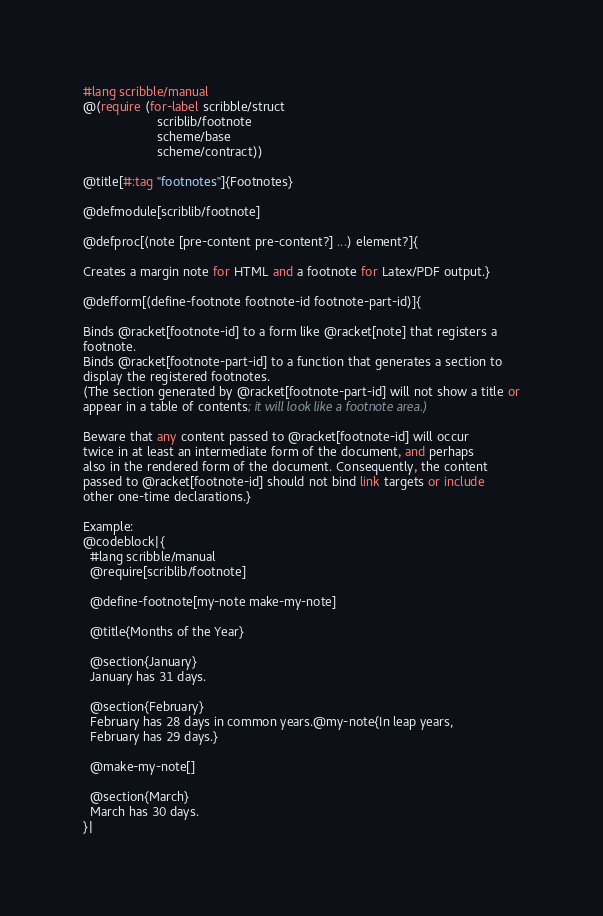Convert code to text. <code><loc_0><loc_0><loc_500><loc_500><_Racket_>#lang scribble/manual
@(require (for-label scribble/struct
                     scriblib/footnote
                     scheme/base
                     scheme/contract))

@title[#:tag "footnotes"]{Footnotes}

@defmodule[scriblib/footnote]

@defproc[(note [pre-content pre-content?] ...) element?]{

Creates a margin note for HTML and a footnote for Latex/PDF output.}

@defform[(define-footnote footnote-id footnote-part-id)]{

Binds @racket[footnote-id] to a form like @racket[note] that registers a
footnote.
Binds @racket[footnote-part-id] to a function that generates a section to
display the registered footnotes.
(The section generated by @racket[footnote-part-id] will not show a title or
appear in a table of contents; it will look like a footnote area.)

Beware that any content passed to @racket[footnote-id] will occur
twice in at least an intermediate form of the document, and perhaps
also in the rendered form of the document. Consequently, the content
passed to @racket[footnote-id] should not bind link targets or include
other one-time declarations.}

Example:
@codeblock|{
  #lang scribble/manual
  @require[scriblib/footnote]

  @define-footnote[my-note make-my-note]

  @title{Months of the Year}

  @section{January}
  January has 31 days.

  @section{February}
  February has 28 days in common years.@my-note{In leap years,
  February has 29 days.}

  @make-my-note[]

  @section{March}
  March has 30 days.
}|
</code> 